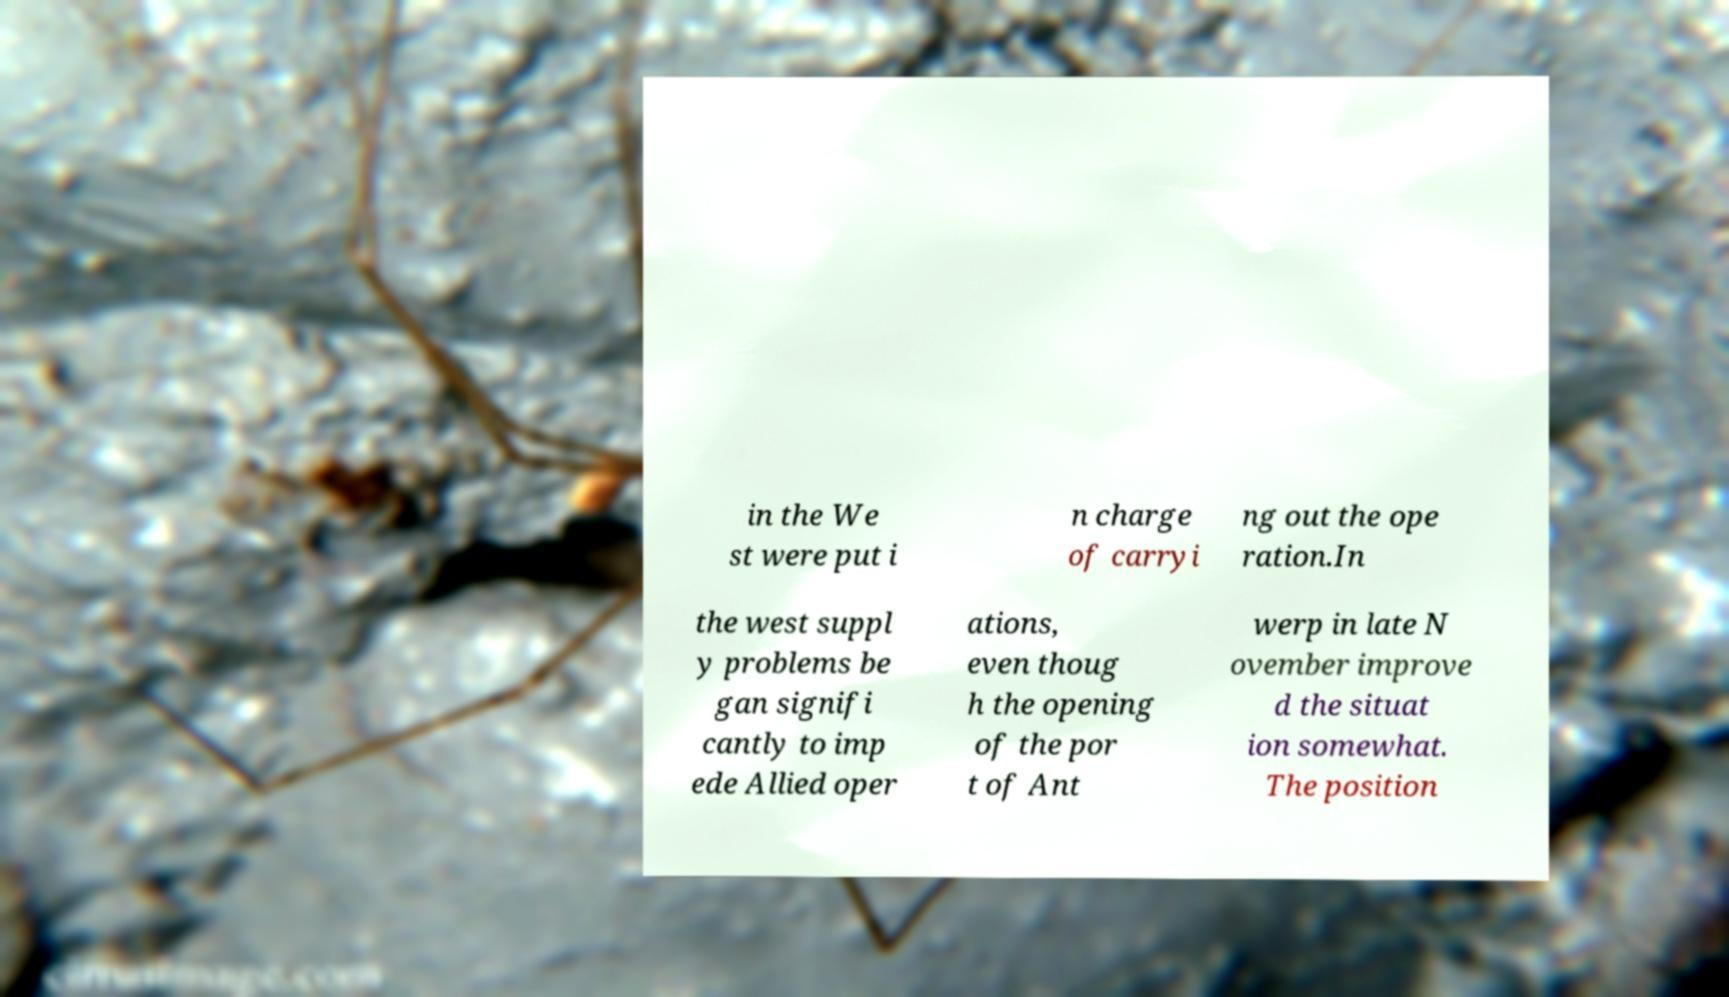Please identify and transcribe the text found in this image. in the We st were put i n charge of carryi ng out the ope ration.In the west suppl y problems be gan signifi cantly to imp ede Allied oper ations, even thoug h the opening of the por t of Ant werp in late N ovember improve d the situat ion somewhat. The position 